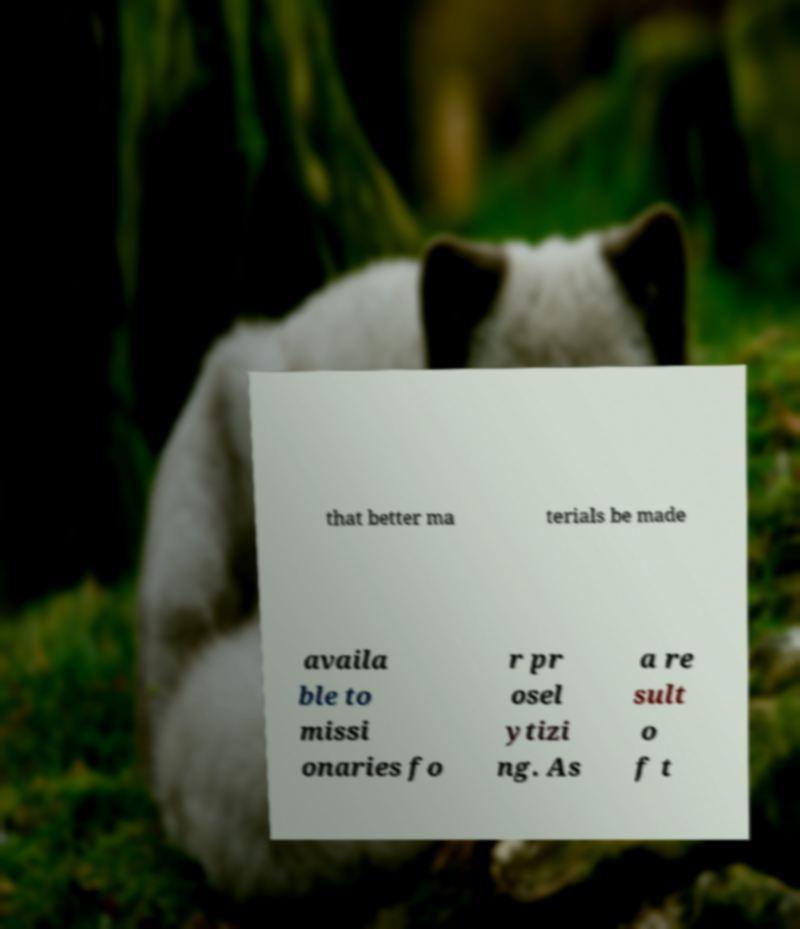For documentation purposes, I need the text within this image transcribed. Could you provide that? that better ma terials be made availa ble to missi onaries fo r pr osel ytizi ng. As a re sult o f t 